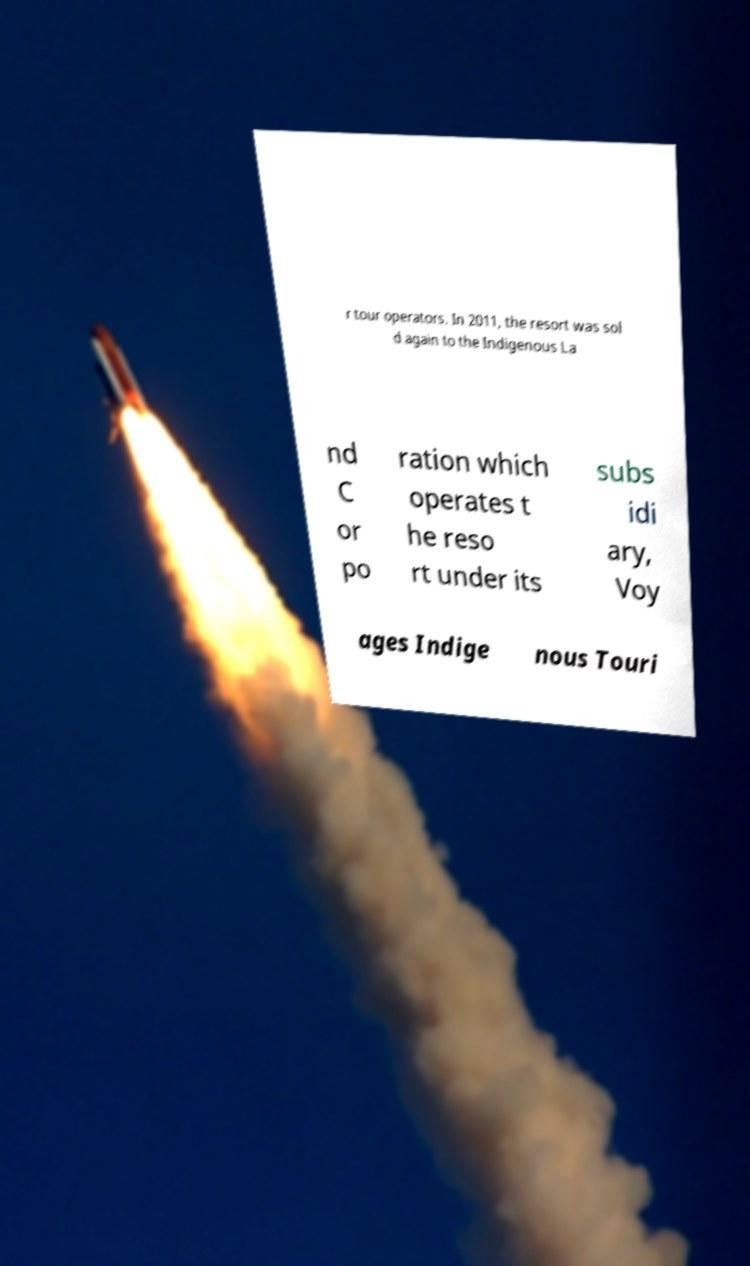Please read and relay the text visible in this image. What does it say? r tour operators. In 2011, the resort was sol d again to the Indigenous La nd C or po ration which operates t he reso rt under its subs idi ary, Voy ages Indige nous Touri 